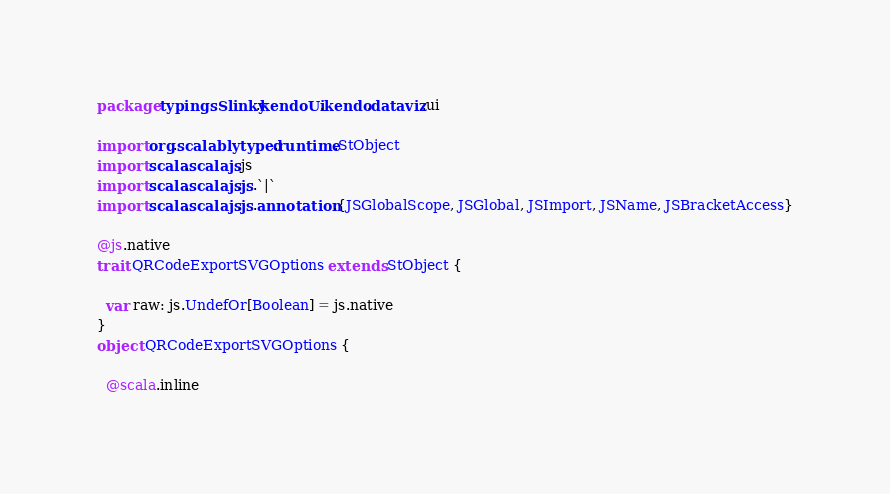Convert code to text. <code><loc_0><loc_0><loc_500><loc_500><_Scala_>package typingsSlinky.kendoUi.kendo.dataviz.ui

import org.scalablytyped.runtime.StObject
import scala.scalajs.js
import scala.scalajs.js.`|`
import scala.scalajs.js.annotation.{JSGlobalScope, JSGlobal, JSImport, JSName, JSBracketAccess}

@js.native
trait QRCodeExportSVGOptions extends StObject {
  
  var raw: js.UndefOr[Boolean] = js.native
}
object QRCodeExportSVGOptions {
  
  @scala.inline</code> 